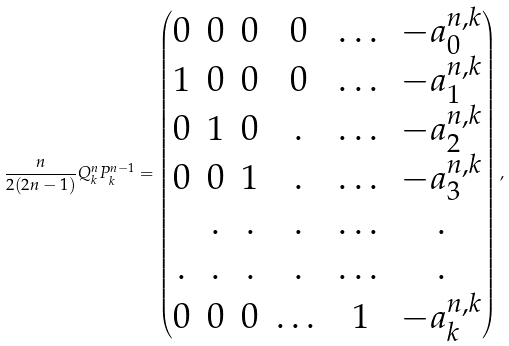<formula> <loc_0><loc_0><loc_500><loc_500>\frac { n } { 2 ( 2 n - 1 ) } Q ^ { n } _ { k } P ^ { n - 1 } _ { k } = \left ( \begin{matrix} 0 & 0 & 0 & 0 & \dots & - a _ { 0 } ^ { n , k } \\ 1 & 0 & 0 & 0 & \dots & - a _ { 1 } ^ { n , k } \\ 0 & 1 & 0 & . & \dots & - a _ { 2 } ^ { n , k } \\ 0 & 0 & 1 & . & \dots & - a _ { 3 } ^ { n , k } \\ & . & . & . & \dots & . \\ . & . & . & . & \dots & . \\ 0 & 0 & 0 & \dots & 1 & - a _ { k } ^ { n , k } \\ \end{matrix} \right ) ,</formula> 